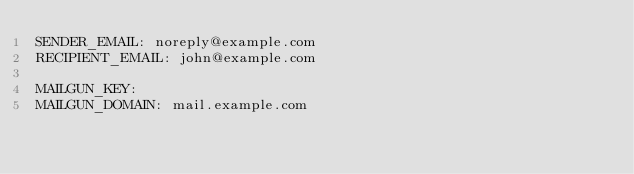Convert code to text. <code><loc_0><loc_0><loc_500><loc_500><_YAML_>SENDER_EMAIL: noreply@example.com
RECIPIENT_EMAIL: john@example.com

MAILGUN_KEY:
MAILGUN_DOMAIN: mail.example.com
</code> 